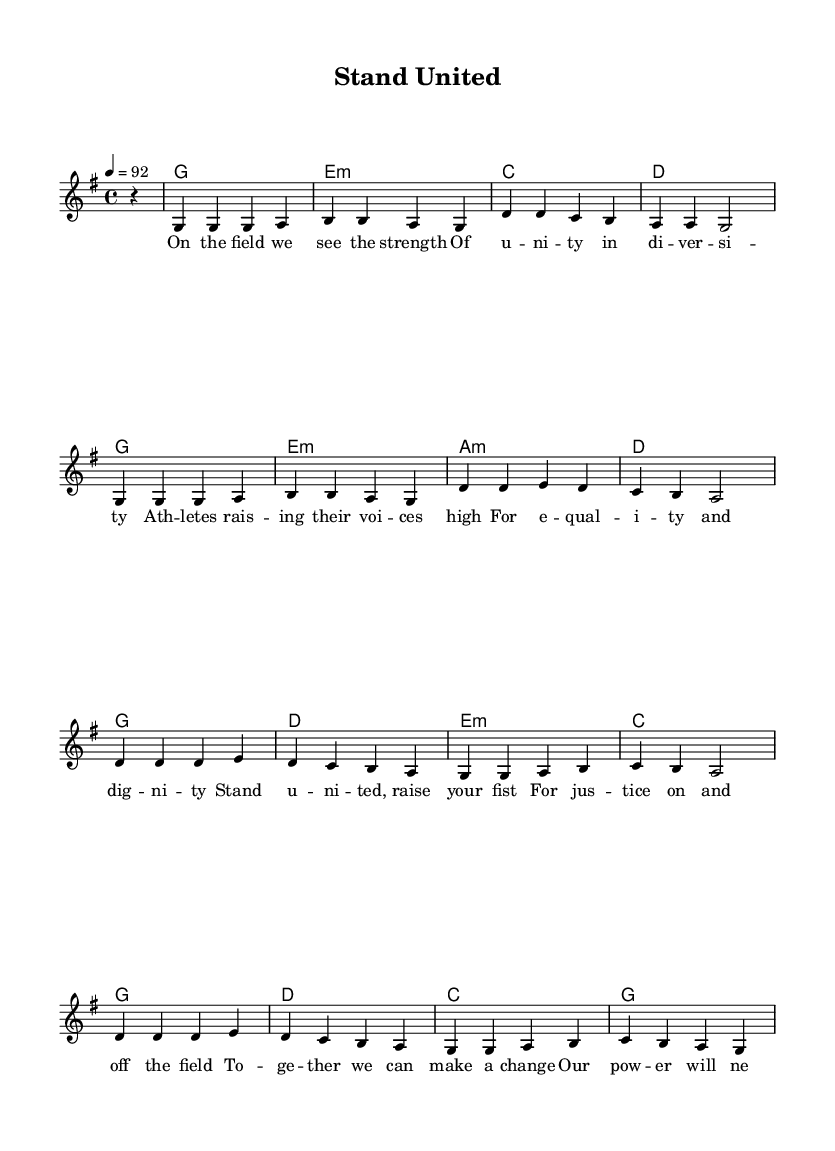What is the key signature of this music? The key signature is G major, which has one sharp (F#).
Answer: G major What is the time signature of this music? The time signature given in the score is 4/4, indicating four beats in each measure.
Answer: 4/4 What is the tempo marking for this piece? The tempo marking indicates a speed of 92 beats per minute.
Answer: 92 How many measures are in the chorus section? The chorus section consists of four measures, as indicated by the repeated lyrical structure.
Answer: Four measures What is the first chord of the song? The first chord listed is G major, which corresponds with the key signature.
Answer: G What is the primary theme of the lyrics? The lyrics focus on unity and social justice, specifically in the context of sports and equality.
Answer: Unity and social justice How many different chords are used in the chorus? The chorus utilizes three distinct chords: G, A minor, and C major, repeated within the structure.
Answer: Three chords 